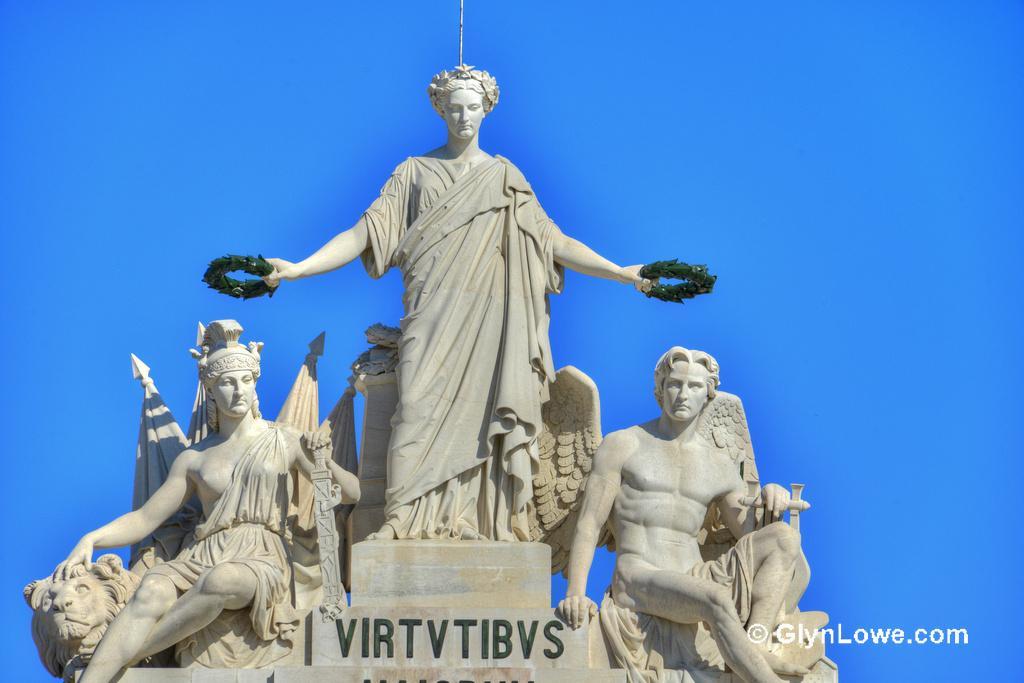Can you describe this image briefly? In the image I can see statues. At the bottom of the image I can see some text. 